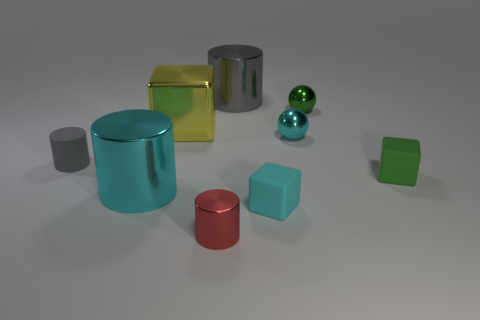Subtract all large cyan metal cylinders. How many cylinders are left? 3 Add 1 cyan metallic cylinders. How many objects exist? 10 Subtract all purple balls. How many gray cylinders are left? 2 Subtract all green spheres. How many spheres are left? 1 Subtract all balls. How many objects are left? 7 Add 5 green metallic objects. How many green metallic objects are left? 6 Add 6 red metal things. How many red metal things exist? 7 Subtract 1 cyan cylinders. How many objects are left? 8 Subtract 4 cylinders. How many cylinders are left? 0 Subtract all blue cubes. Subtract all cyan spheres. How many cubes are left? 3 